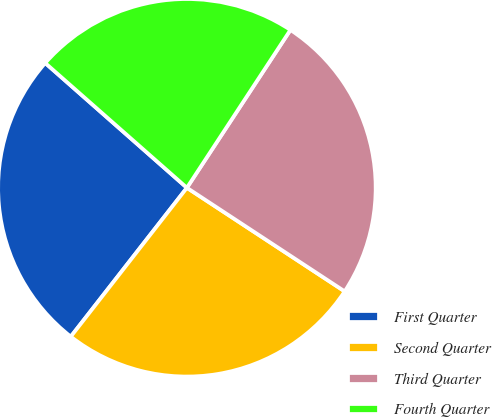Convert chart to OTSL. <chart><loc_0><loc_0><loc_500><loc_500><pie_chart><fcel>First Quarter<fcel>Second Quarter<fcel>Third Quarter<fcel>Fourth Quarter<nl><fcel>25.95%<fcel>26.3%<fcel>25.01%<fcel>22.75%<nl></chart> 